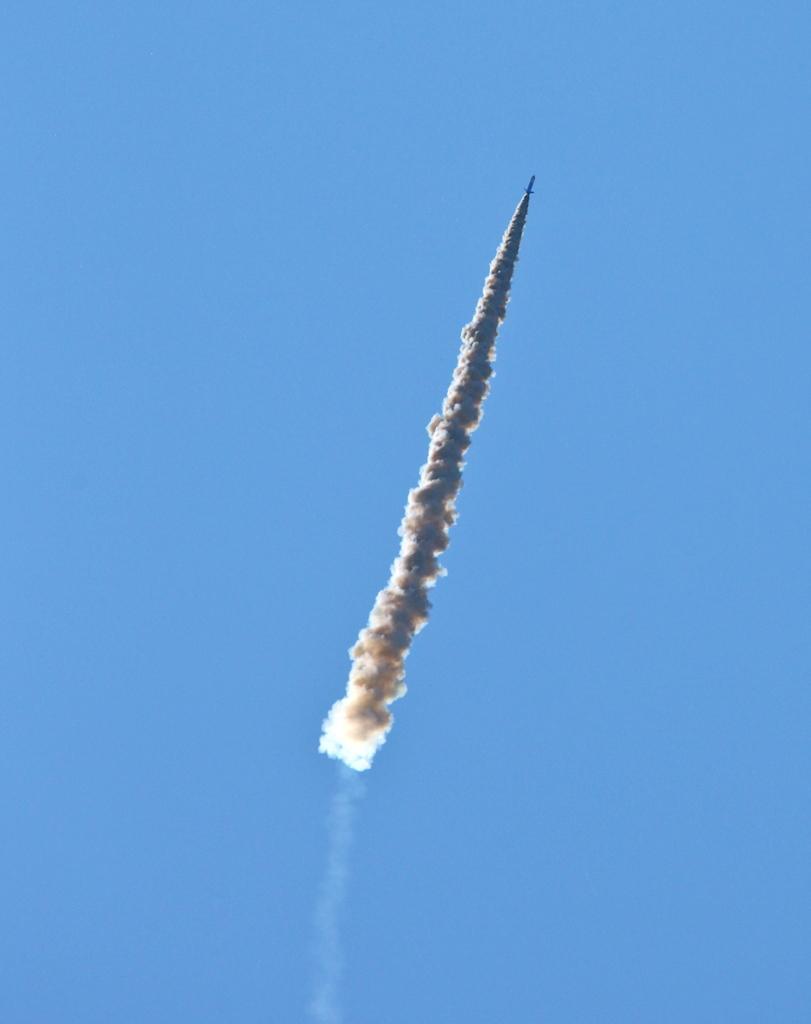What is the main subject of the image? There is a rocket in the image. Where is the rocket located? The rocket is in the sky. What else can be seen in the image besides the rocket? There is smoke visible in the image. Can you see any fairies flying around the rocket in the image? There are no fairies present in the image; it only features a rocket and smoke. What time of day is the rocket launch taking place in the image? The time of day cannot be determined from the image, as there is no information about the lighting or shadows. 